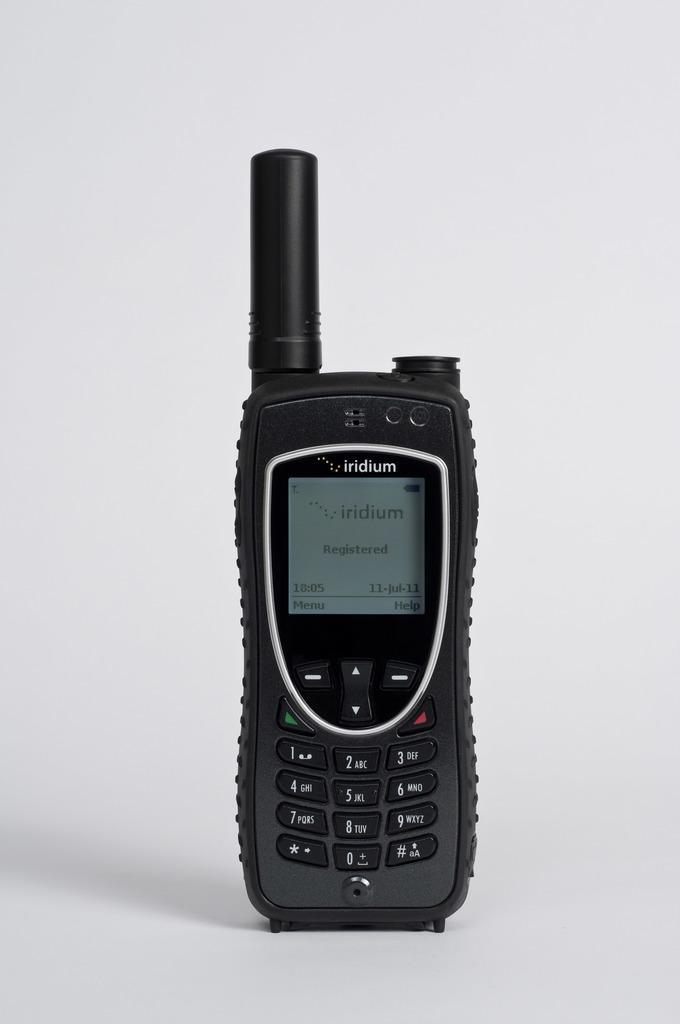In one or two sentences, can you explain what this image depicts? In this image the background is gray in color. In the middle of the image there is a mobile phone on the surface. The phone is black in color. 